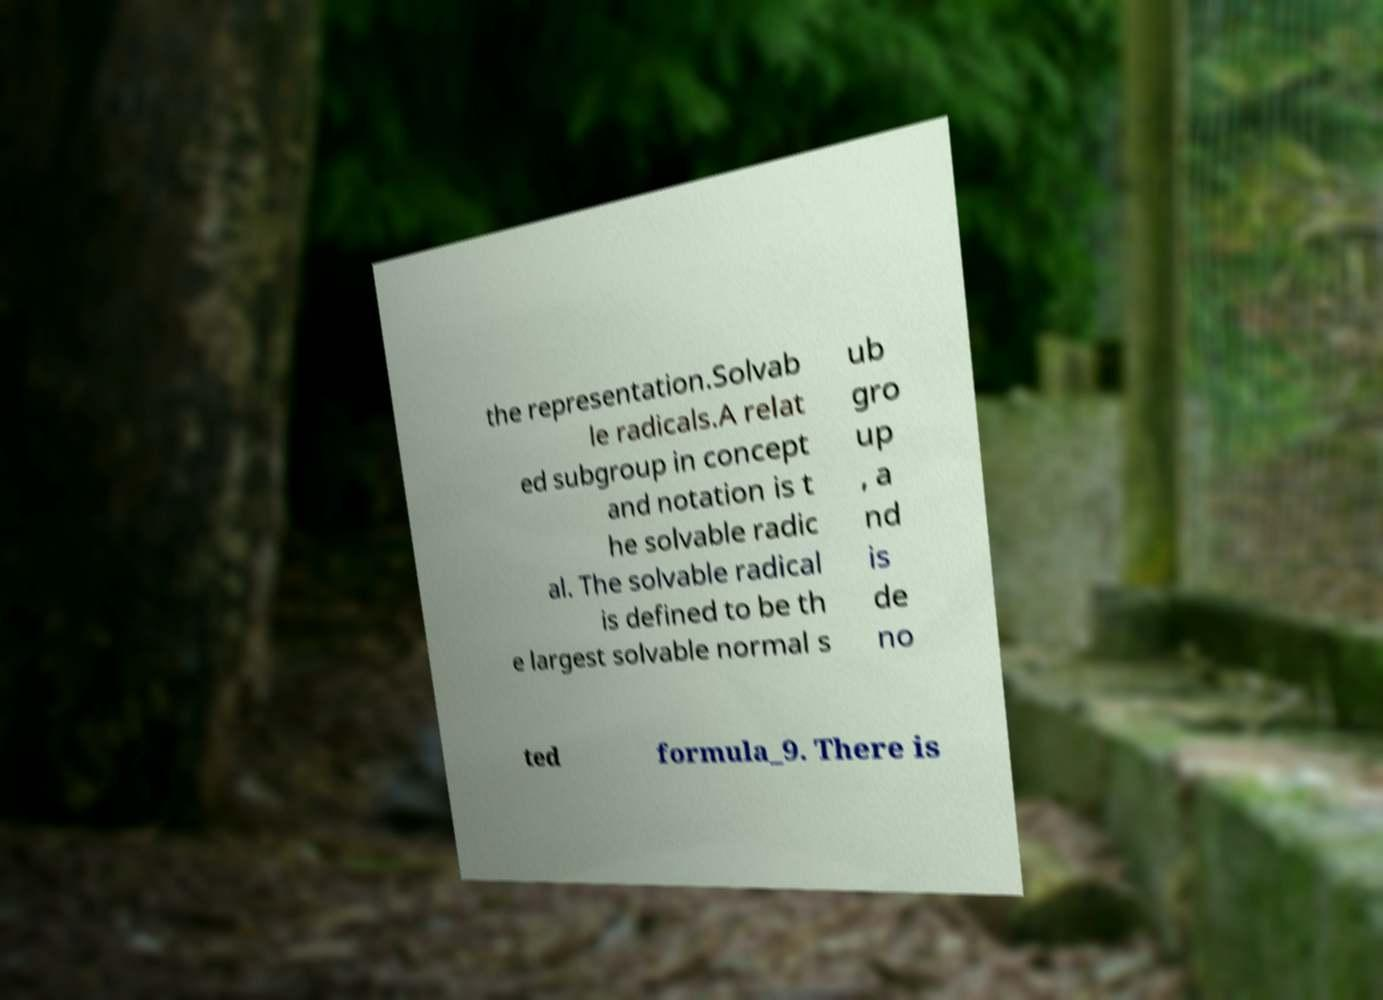What messages or text are displayed in this image? I need them in a readable, typed format. the representation.Solvab le radicals.A relat ed subgroup in concept and notation is t he solvable radic al. The solvable radical is defined to be th e largest solvable normal s ub gro up , a nd is de no ted formula_9. There is 